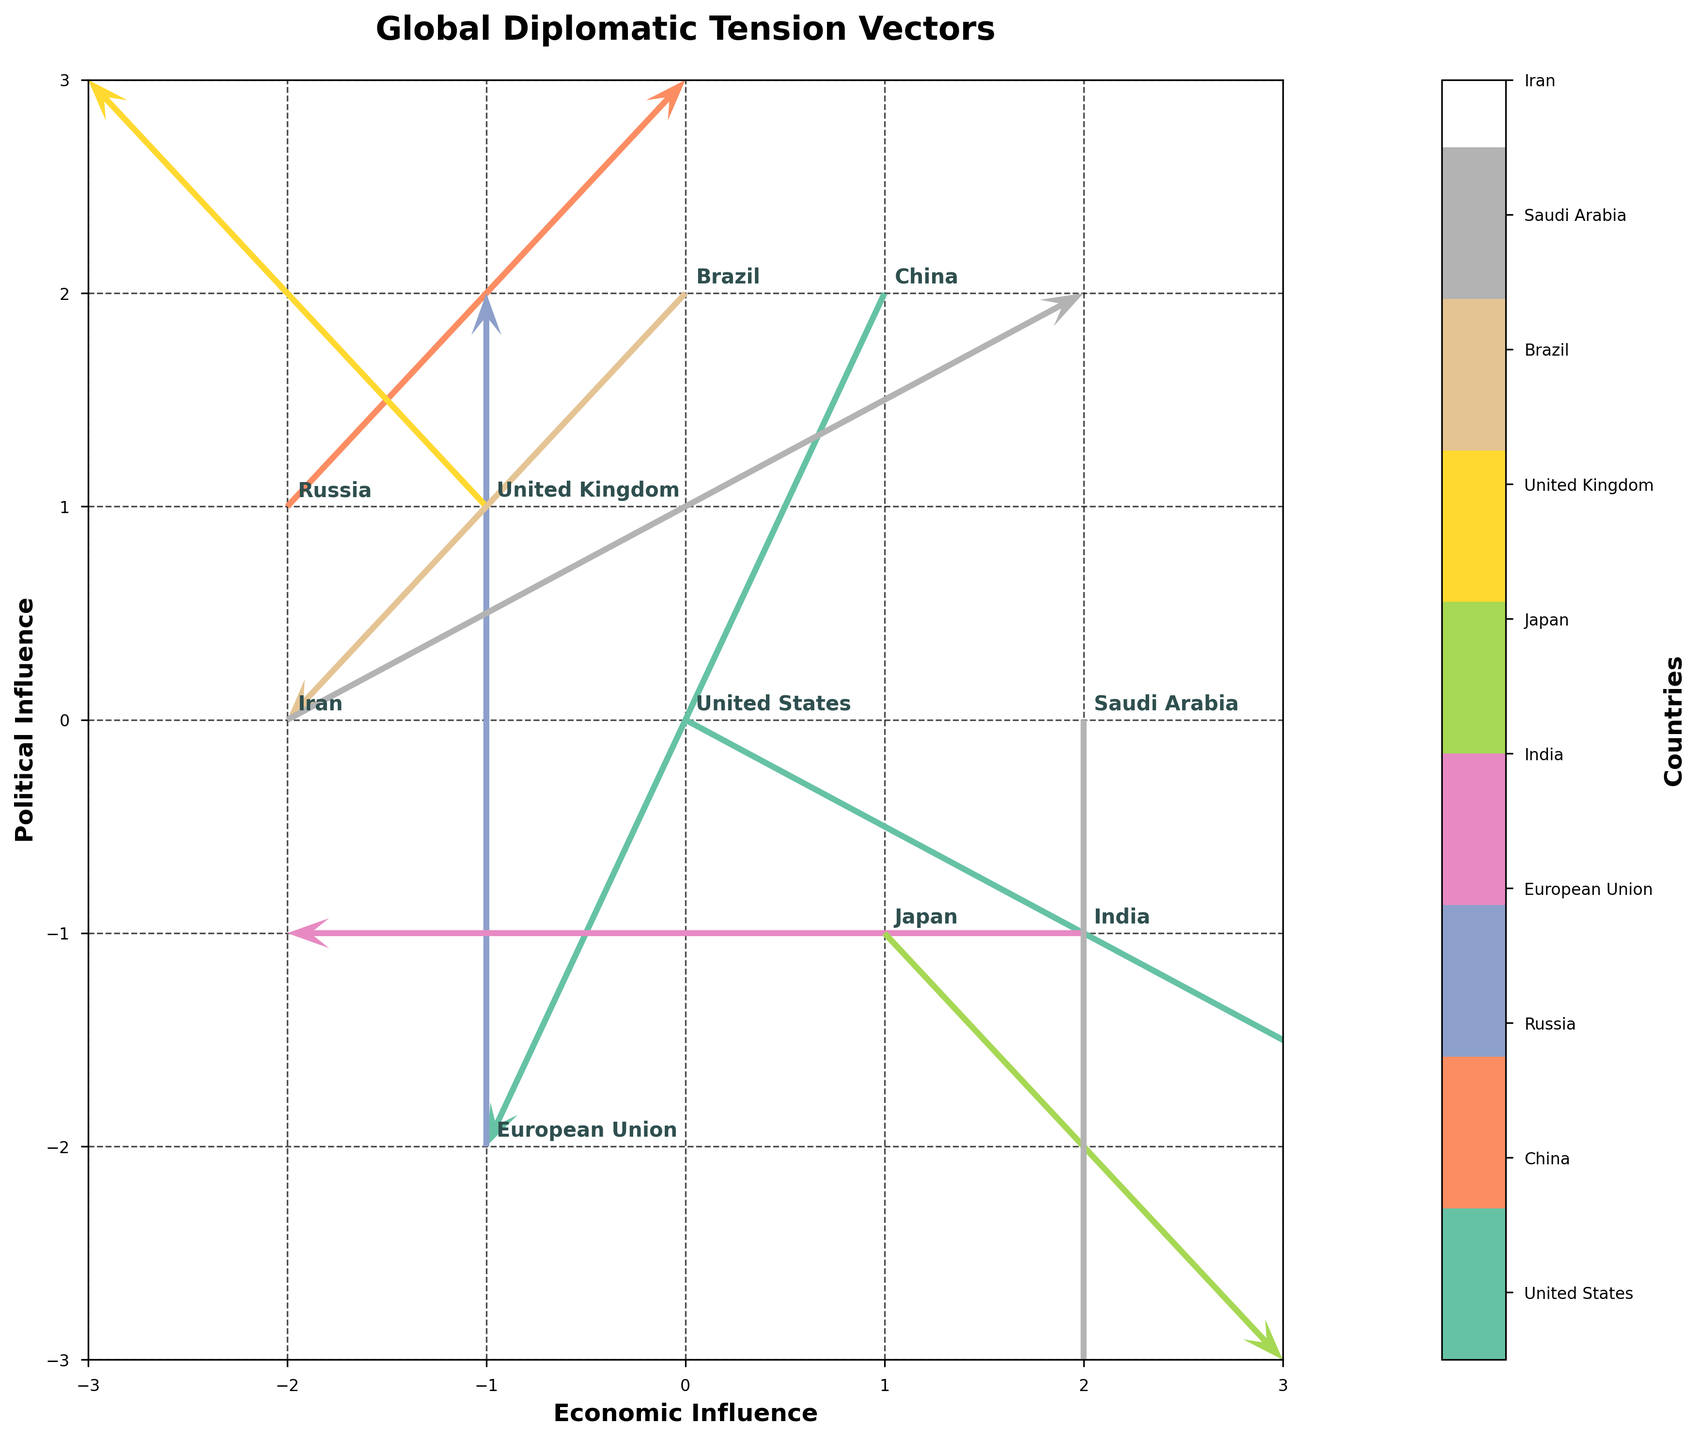What's the title of the figure? The title of the figure is displayed at the top and provides an overview of what the graph represents.
Answer: Global Diplomatic Tension Vectors How many countries are represented in the figure? Counting the labels associated with each vector in the plot, we can see there are ten different countries.
Answer: 10 Which country has a vector pointing directly downward? Observing the direction of the vectors, the country with a vector originating from (2,0) and pointing directly downward is noticeable.
Answer: Saudi Arabia Identify the country whose vector has components U=0 and V=2. By examining the vector components, we note that the country with U=0 and V=2 is situated at (-1, -2).
Answer: European Union Which country has the most significant positive economic influence? The country with the highest positive X-component in their vector signifies the most substantial positive economic influence, originating from (0,0) and extends to the right.
Answer: United States What's the average U component of the vectors for China and Iran? China has U=-1, and Iran has U=2. The average is calculated as (−1 + 2) / 2 = 0.5.
Answer: 0.5 Which country's vector indicates the highest combination of positive economic and political influence? A vector with both components positive and originating at coordinates gives insight into combined influence, focusing on the country whose vector extends both positively on X and Y axes.
Answer: Russia Which country has a negative political influence but neutral economic influence? The country with U=0, indicating neutral economic influence, and a V component indicating vertical direction gives the answer.
Answer: European Union Compare the political influence vectors of China and Japan. Which country has a more negative political influence? China's vector has a Y-component of -2, and Japan has a Y-component of -1. A lower V value indicates more negative influence.
Answer: China What's the combined total political influence of United Kingdom and Brazil? Adding the Y-components of the vectors for United Kingdom (V=1) and Brazil (V= -1) gives 1 + (-1) = 0.
Answer: 0 